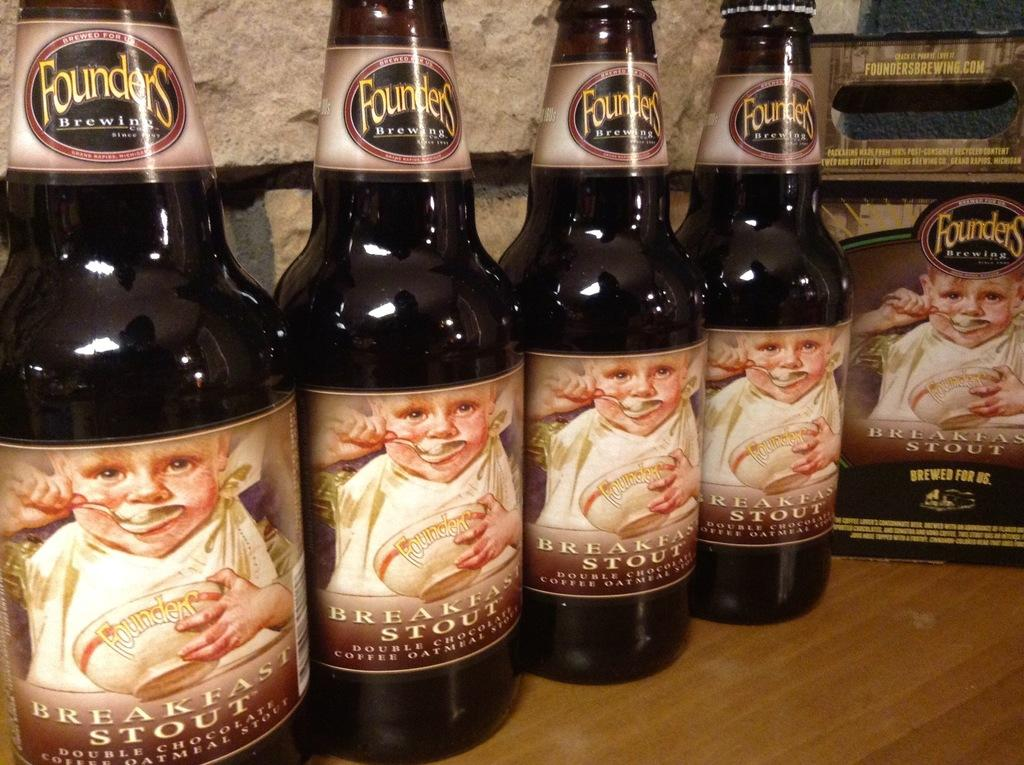<image>
Provide a brief description of the given image. Bottles of Breakfast Stout beer with a baby eating on the label 